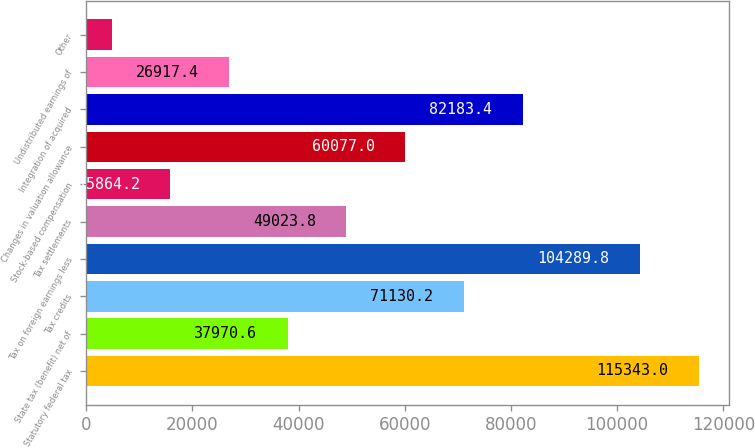Convert chart. <chart><loc_0><loc_0><loc_500><loc_500><bar_chart><fcel>Statutory federal tax<fcel>State tax (benefit) net of<fcel>Tax credits<fcel>Tax on foreign earnings less<fcel>Tax settlements<fcel>Stock-based compensation<fcel>Changes in valuation allowance<fcel>Integration of acquired<fcel>Undistributed earnings of<fcel>Other<nl><fcel>115343<fcel>37970.6<fcel>71130.2<fcel>104290<fcel>49023.8<fcel>15864.2<fcel>60077<fcel>82183.4<fcel>26917.4<fcel>4811<nl></chart> 